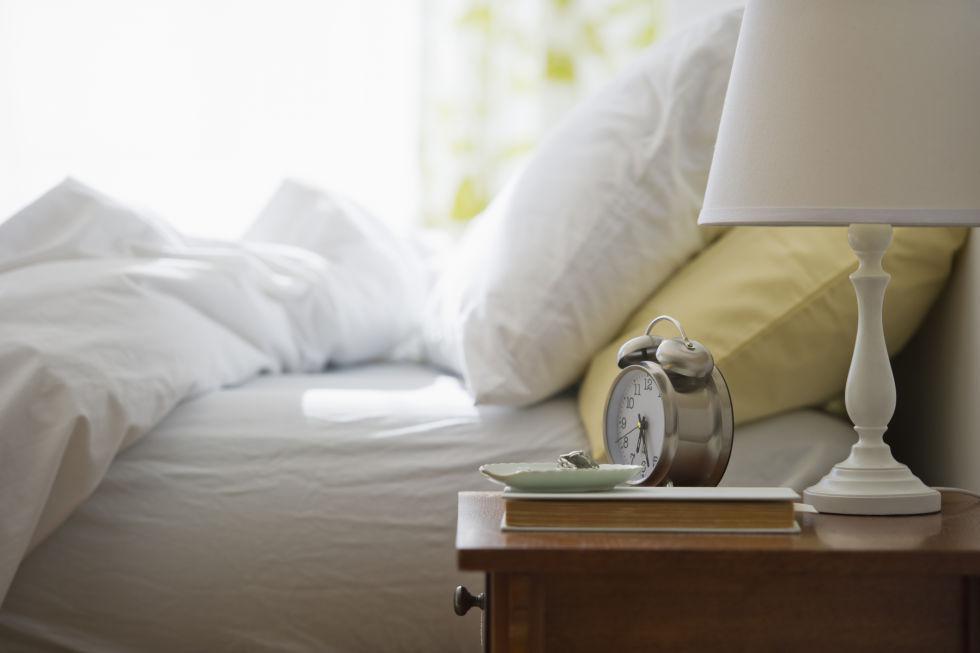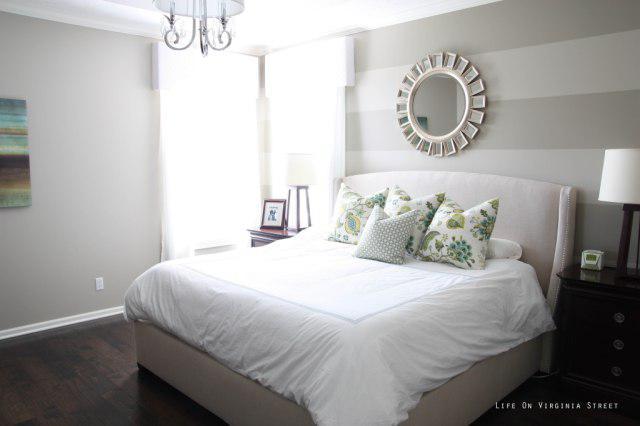The first image is the image on the left, the second image is the image on the right. Examine the images to the left and right. Is the description "An image shows a person with bare legs on a bed next to a window with a fabric drape." accurate? Answer yes or no. No. The first image is the image on the left, the second image is the image on the right. Analyze the images presented: Is the assertion "A person is laying in the bed in the image on the left." valid? Answer yes or no. No. 